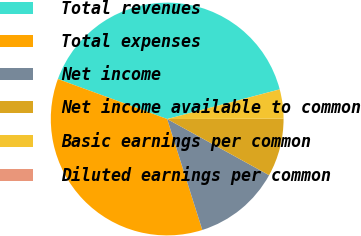Convert chart. <chart><loc_0><loc_0><loc_500><loc_500><pie_chart><fcel>Total revenues<fcel>Total expenses<fcel>Net income<fcel>Net income available to common<fcel>Basic earnings per common<fcel>Diluted earnings per common<nl><fcel>40.31%<fcel>35.46%<fcel>12.1%<fcel>8.07%<fcel>4.04%<fcel>0.01%<nl></chart> 